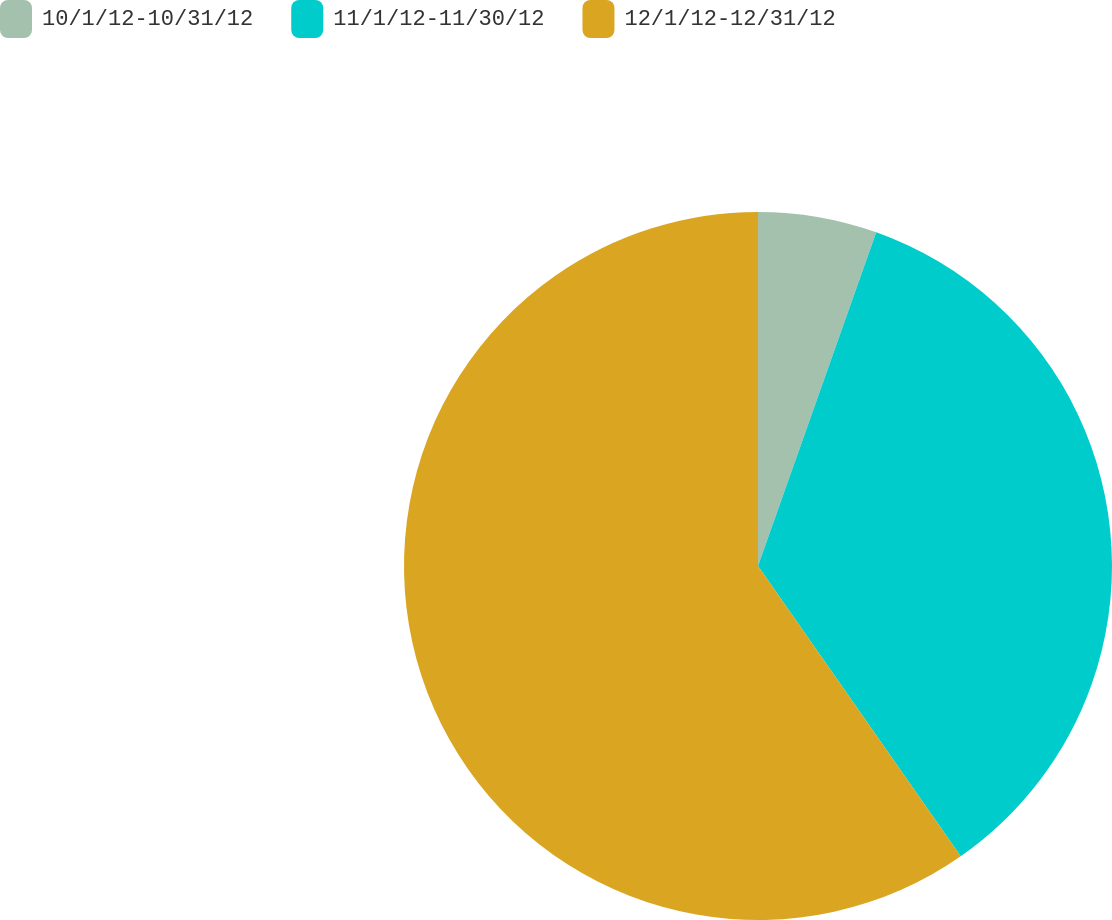Convert chart. <chart><loc_0><loc_0><loc_500><loc_500><pie_chart><fcel>10/1/12-10/31/12<fcel>11/1/12-11/30/12<fcel>12/1/12-12/31/12<nl><fcel>5.42%<fcel>34.88%<fcel>59.71%<nl></chart> 